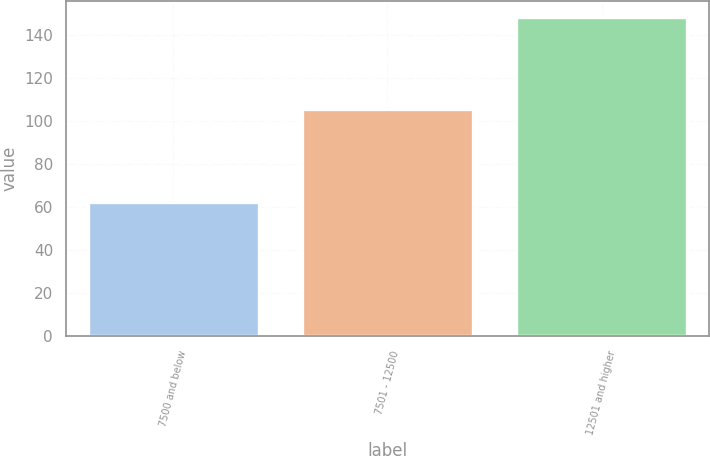Convert chart to OTSL. <chart><loc_0><loc_0><loc_500><loc_500><bar_chart><fcel>7500 and below<fcel>7501 - 12500<fcel>12501 and higher<nl><fcel>62.36<fcel>105.54<fcel>148.4<nl></chart> 